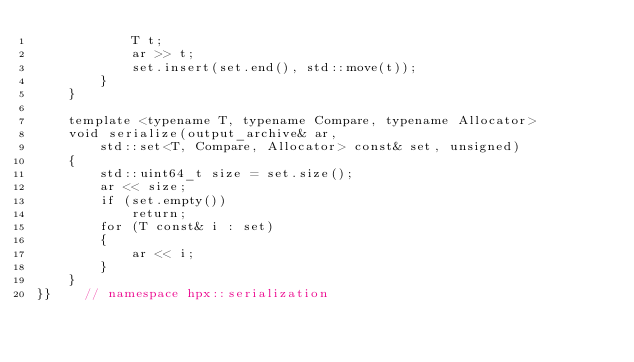Convert code to text. <code><loc_0><loc_0><loc_500><loc_500><_C++_>            T t;
            ar >> t;
            set.insert(set.end(), std::move(t));
        }
    }

    template <typename T, typename Compare, typename Allocator>
    void serialize(output_archive& ar,
        std::set<T, Compare, Allocator> const& set, unsigned)
    {
        std::uint64_t size = set.size();
        ar << size;
        if (set.empty())
            return;
        for (T const& i : set)
        {
            ar << i;
        }
    }
}}    // namespace hpx::serialization
</code> 